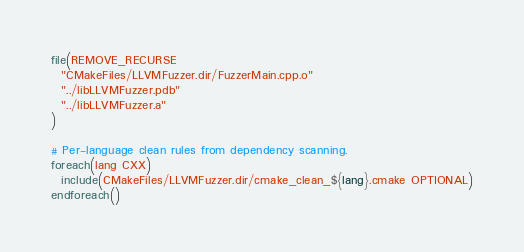Convert code to text. <code><loc_0><loc_0><loc_500><loc_500><_CMake_>file(REMOVE_RECURSE
  "CMakeFiles/LLVMFuzzer.dir/FuzzerMain.cpp.o"
  "../libLLVMFuzzer.pdb"
  "../libLLVMFuzzer.a"
)

# Per-language clean rules from dependency scanning.
foreach(lang CXX)
  include(CMakeFiles/LLVMFuzzer.dir/cmake_clean_${lang}.cmake OPTIONAL)
endforeach()
</code> 